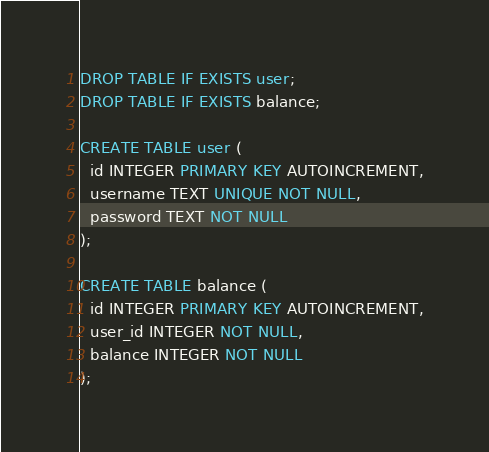Convert code to text. <code><loc_0><loc_0><loc_500><loc_500><_SQL_>DROP TABLE IF EXISTS user;
DROP TABLE IF EXISTS balance;

CREATE TABLE user (
  id INTEGER PRIMARY KEY AUTOINCREMENT,
  username TEXT UNIQUE NOT NULL,
  password TEXT NOT NULL
);

CREATE TABLE balance (
  id INTEGER PRIMARY KEY AUTOINCREMENT,
  user_id INTEGER NOT NULL,
  balance INTEGER NOT NULL
);
</code> 